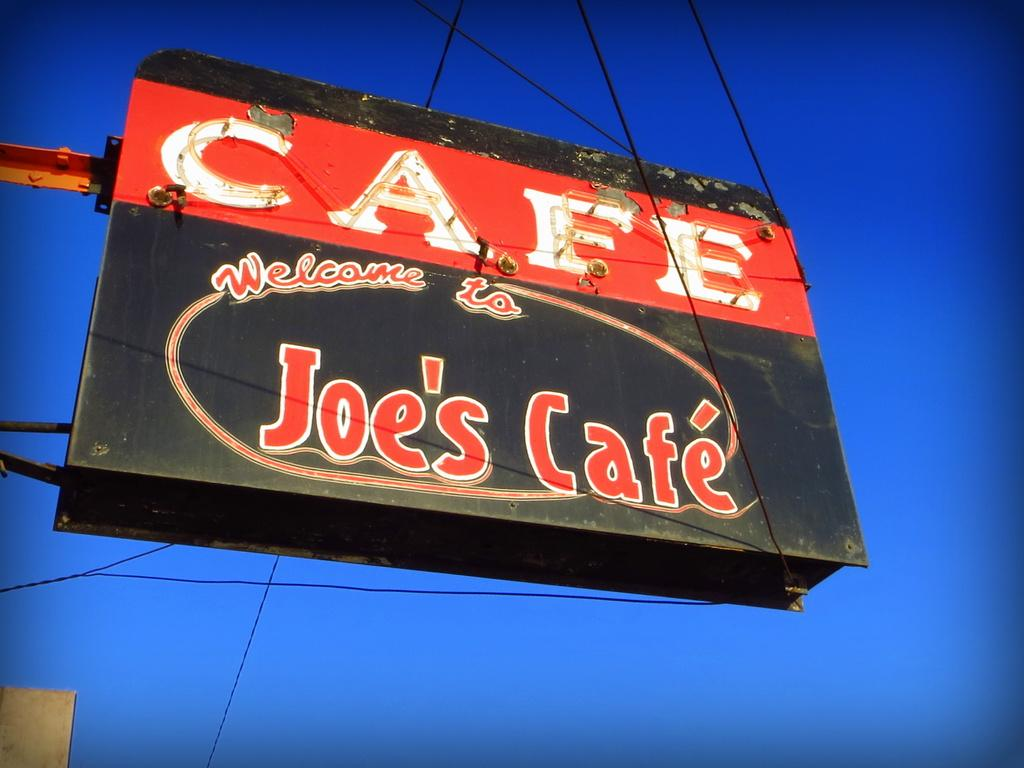<image>
Share a concise interpretation of the image provided. A from below shot of a black and red sign advertising Joes Cafe 